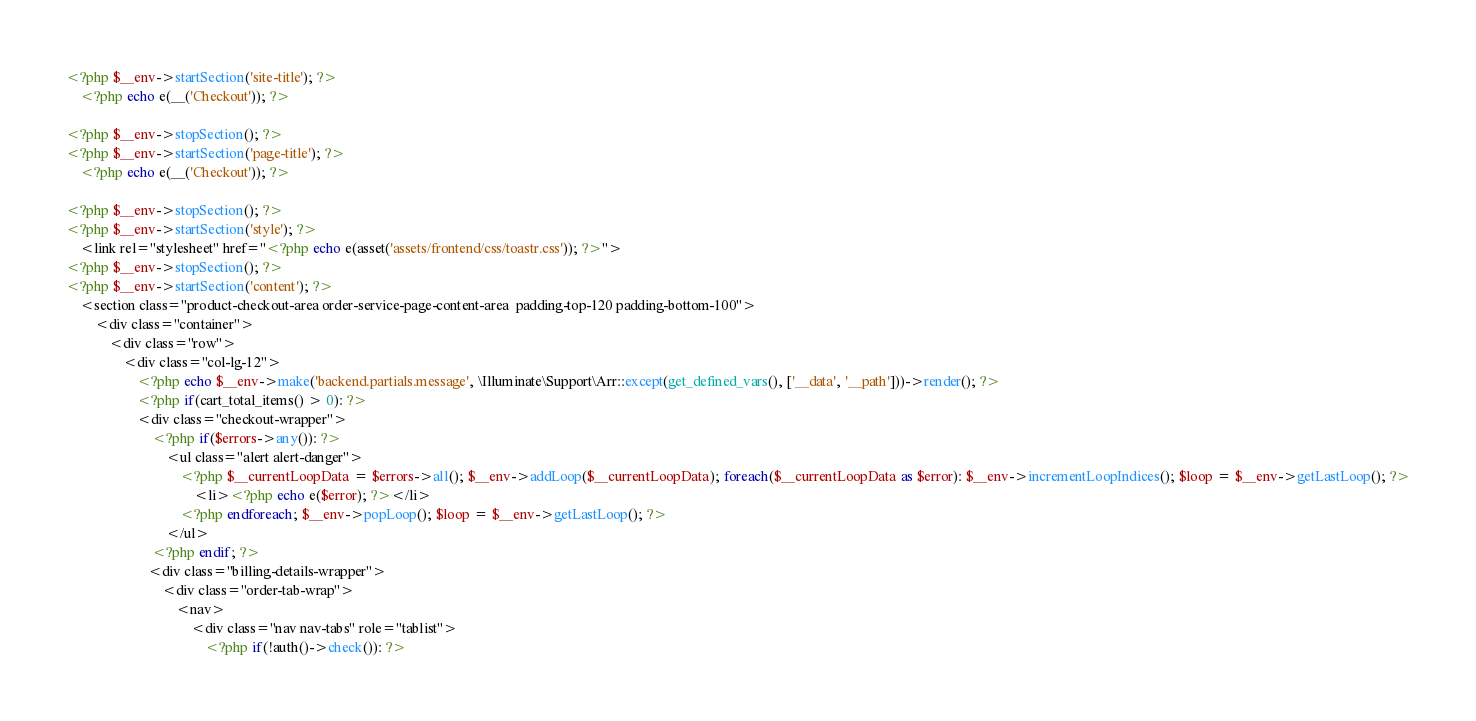<code> <loc_0><loc_0><loc_500><loc_500><_PHP_><?php $__env->startSection('site-title'); ?>
    <?php echo e(__('Checkout')); ?>

<?php $__env->stopSection(); ?>
<?php $__env->startSection('page-title'); ?>
    <?php echo e(__('Checkout')); ?>

<?php $__env->stopSection(); ?>
<?php $__env->startSection('style'); ?>
    <link rel="stylesheet" href="<?php echo e(asset('assets/frontend/css/toastr.css')); ?>">
<?php $__env->stopSection(); ?>
<?php $__env->startSection('content'); ?>
    <section class="product-checkout-area order-service-page-content-area  padding-top-120 padding-bottom-100">
        <div class="container">
            <div class="row">
                <div class="col-lg-12">
                    <?php echo $__env->make('backend.partials.message', \Illuminate\Support\Arr::except(get_defined_vars(), ['__data', '__path']))->render(); ?>
                    <?php if(cart_total_items() > 0): ?>
                    <div class="checkout-wrapper">
                        <?php if($errors->any()): ?>
                            <ul class="alert alert-danger">
                                <?php $__currentLoopData = $errors->all(); $__env->addLoop($__currentLoopData); foreach($__currentLoopData as $error): $__env->incrementLoopIndices(); $loop = $__env->getLastLoop(); ?>
                                    <li><?php echo e($error); ?></li>
                                <?php endforeach; $__env->popLoop(); $loop = $__env->getLastLoop(); ?>
                            </ul>
                        <?php endif; ?>
                       <div class="billing-details-wrapper">
                           <div class="order-tab-wrap">
                               <nav>
                                   <div class="nav nav-tabs" role="tablist">
                                       <?php if(!auth()->check()): ?></code> 